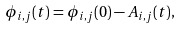Convert formula to latex. <formula><loc_0><loc_0><loc_500><loc_500>\phi _ { i , j } ( t ) = \phi _ { i , j } ( 0 ) - A _ { i , j } ( t ) ,</formula> 